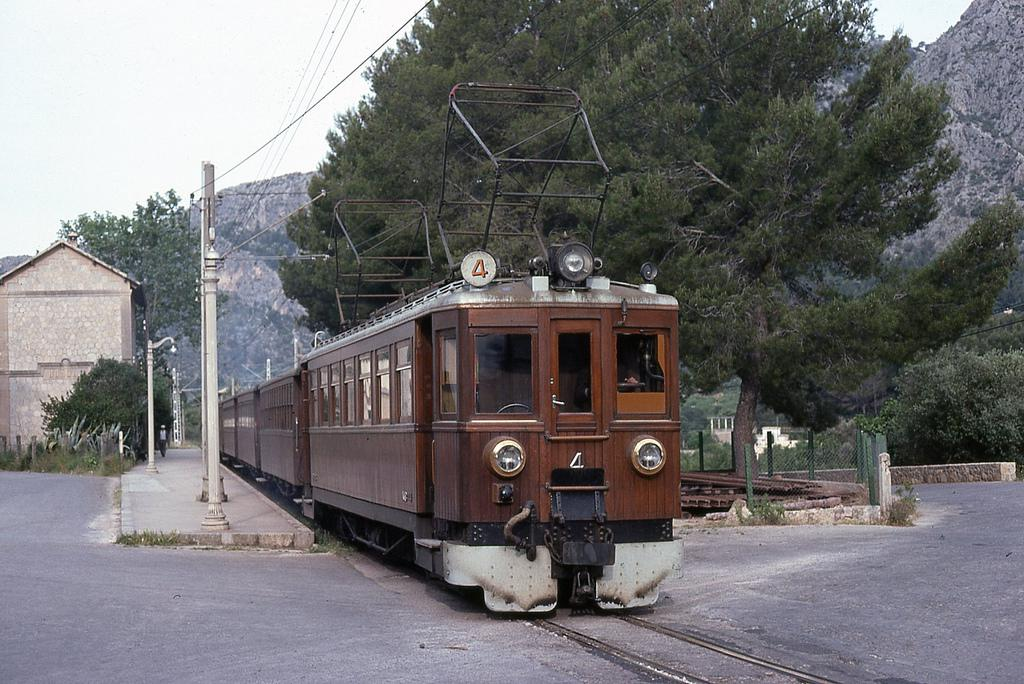Question: who drives a train?
Choices:
A. An engineer.
B. A conductor.
C. The driver.
D. The operator.
Answer with the letter. Answer: B Question: where is the light pole?
Choices:
A. To the right of the train.
B. To the left of the train.
C. Behind the train.
D. Above the train.
Answer with the letter. Answer: B Question: why are their lights on the train?
Choices:
A. To see road crossings.
B. To see objects on the track.
C. To see other trains.
D. To see things in the yard.
Answer with the letter. Answer: B Question: what kind of building is to the left of the train?
Choices:
A. Stucco.
B. Brick.
C. Wood.
D. Stone.
Answer with the letter. Answer: B Question: when was the photo taken?
Choices:
A. At night.
B. In the evening.
C. During the day.
D. In the afternoon.
Answer with the letter. Answer: C Question: what color is the train?
Choices:
A. Black.
B. Red.
C. Brown.
D. Blue.
Answer with the letter. Answer: C Question: where was the photo taken?
Choices:
A. Near a train.
B. On a bus.
C. Inside a subway terminal.
D. Under a bridge.
Answer with the letter. Answer: A Question: where is the sidewalk?
Choices:
A. By the bus stop.
B. To the left of the train.
C. In front of the building.
D. Across the street.
Answer with the letter. Answer: B Question: where was the photo taken?
Choices:
A. At the bus stop.
B. On a train track.
C. In a parking lot.
D. At an airport.
Answer with the letter. Answer: B Question: how is the day?
Choices:
A. Overcast.
B. Cold.
C. Warm.
D. Gloomy.
Answer with the letter. Answer: A Question: where is the building?
Choices:
A. In the distance.
B. Next to the empty field.
C. On the right of the road.
D. To the left of the train.
Answer with the letter. Answer: D Question: what is on top of the train?
Choices:
A. A number 4.
B. A smoke stack.
C. A person.
D. Luggage.
Answer with the letter. Answer: A Question: how is the sky?
Choices:
A. Clear.
B. Sunny.
C. Overcast.
D. Cloudy.
Answer with the letter. Answer: C Question: what is large and green in the photo?
Choices:
A. A bush.
B. A car.
C. A barn.
D. A tree.
Answer with the letter. Answer: D Question: what lines the sidewalk?
Choices:
A. Pedestrian lanes.
B. Railings.
C. People.
D. Street lights.
Answer with the letter. Answer: D Question: what does the train have?
Choices:
A. Ceiling.
B. Driver.
C. Paint.
D. Many windows.
Answer with the letter. Answer: D 